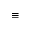<formula> <loc_0><loc_0><loc_500><loc_500>\equiv</formula> 